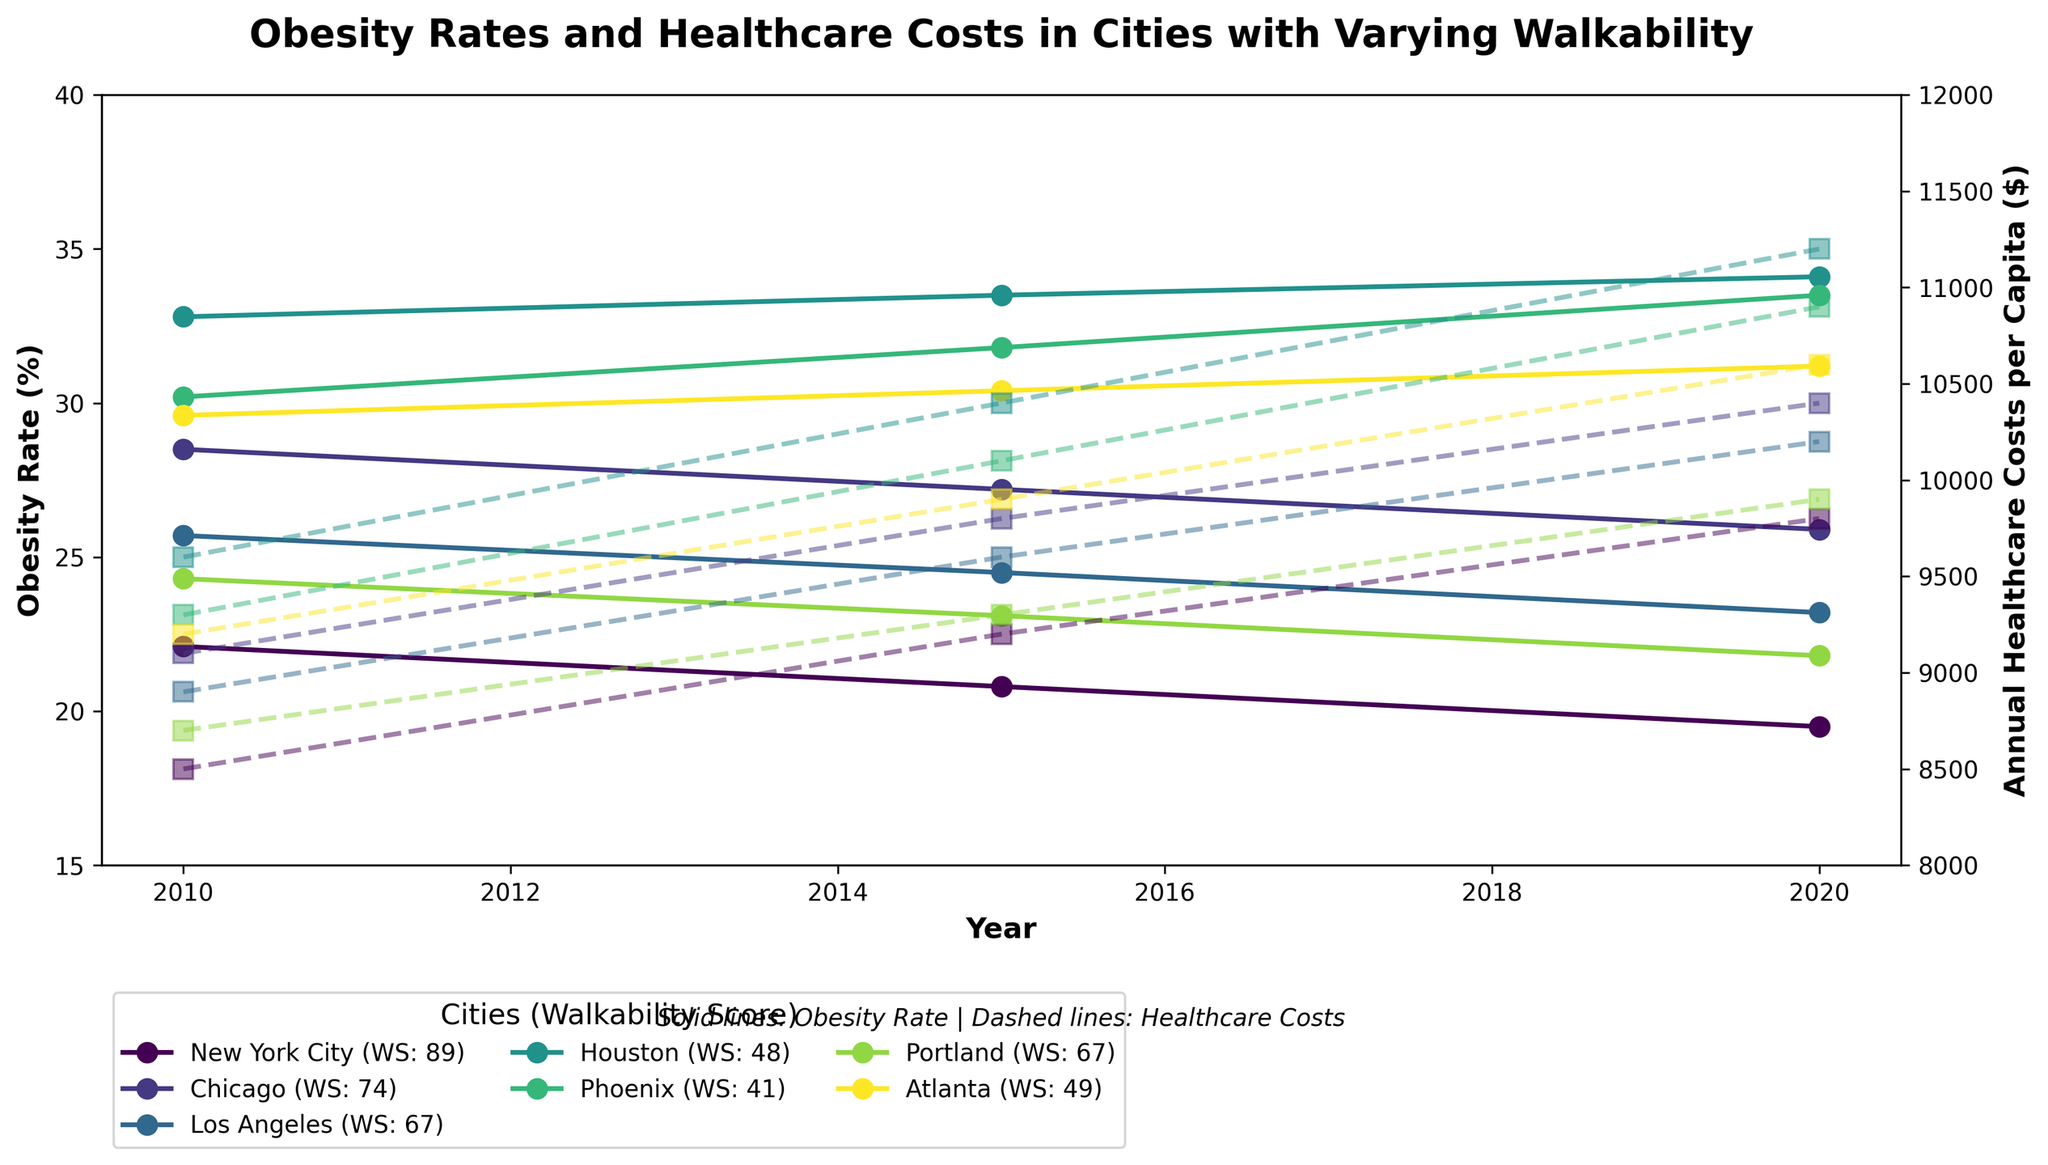What is the general trend of obesity rates in cities with high walkability scores like New York City? Observe the line representing New York City (Walkability Score: 89). From 2010 to 2020, the obesity rate decreases from 22.1% to 19.5%. This indicates a downward trend in obesity rates in highly walkable cities.
Answer: Downward trend How does the annual healthcare cost per capita in Phoenix change from 2010 to 2020? Look at the dashed line representing Phoenix (Walkability Score: 41). From 2010 to 2020, the annual healthcare cost per capita increases from $9300 to $10900.
Answer: Increases Which city had the smallest decrease in obesity rate from 2010 to 2020? Compare the obesity rates across all cities between 2010 and 2020. Houston (Walkability Score: 48) shows an increase in obesity rate from 32.8% to 34.1%, the smallest decrease and an actual increase.
Answer: Houston Compare the change in healthcare costs between New York City and Chicago from 2010 to 2020. For New York City, the healthcare costs increased from $8500 to $9800. For Chicago, the healthcare costs increased from $9100 to $10400. Calculate the change for both: New York (+$1300) and Chicago (+$1300).
Answer: Both increased by $1300 What is the relationship between walkability scores and changes in obesity rates? Compare the cities with higher walkability scores to those with lower scores. Cities like New York City and Portland (higher scores) demonstrate a decrease in obesity rates, while cities like Houston and Phoenix (lower scores) show increases or very little decrease in obesity rates.
Answer: Higher walkability scores generally correlate with decreasing obesity rates Which city showed the highest increase in annual healthcare costs from 2010 to 2020? Examine the lines for each city representing healthcare costs. Houston shows the highest increase in healthcare costs, from $9600 in 2010 to $11200 in 2020.
Answer: Houston How does the obesity rate in Atlanta change from 2010 to 2020, and how does it compare to the obesity rate changes in Portland? Atlanta's obesity rate increases from 29.6% to 31.2%, while Portland's decreases from 24.3% to 21.8%. This shows that Atlanta saw an increase in obesity, whereas Portland saw a decrease.
Answer: Atlanta increased, Portland decreased What was the average annual healthcare cost per capita in 2020 for all cities combined? Add up the healthcare costs for all cities in 2020: ($9800 + $10400 + $10200 + $11200 + $10900 + $9900 + $10600) = $73100, divide by the number of cities (7).
Answer: $10442.86 Which city had the largest difference in obesity rates between 2010 and 2020? Calculate the difference in obesity rates for each city between 2010 and 2020. New York City has the largest difference, with a change from 22.1% to 19.5%, a 2.6% decrease.
Answer: New York City How does the obesity rate in Los Angeles compare to the obesity rate in Portland over the years? Compare the lines representing Los Angeles (WS: 67) and Portland (WS: 67). Los Angeles shows a steady decline from 25.7% to 23.2%, while Portland shows a decline from 24.3% to 21.8%. Overall, both cities show a decline, with Portland having slightly lower rates.
Answer: Both decline, Portland lower 